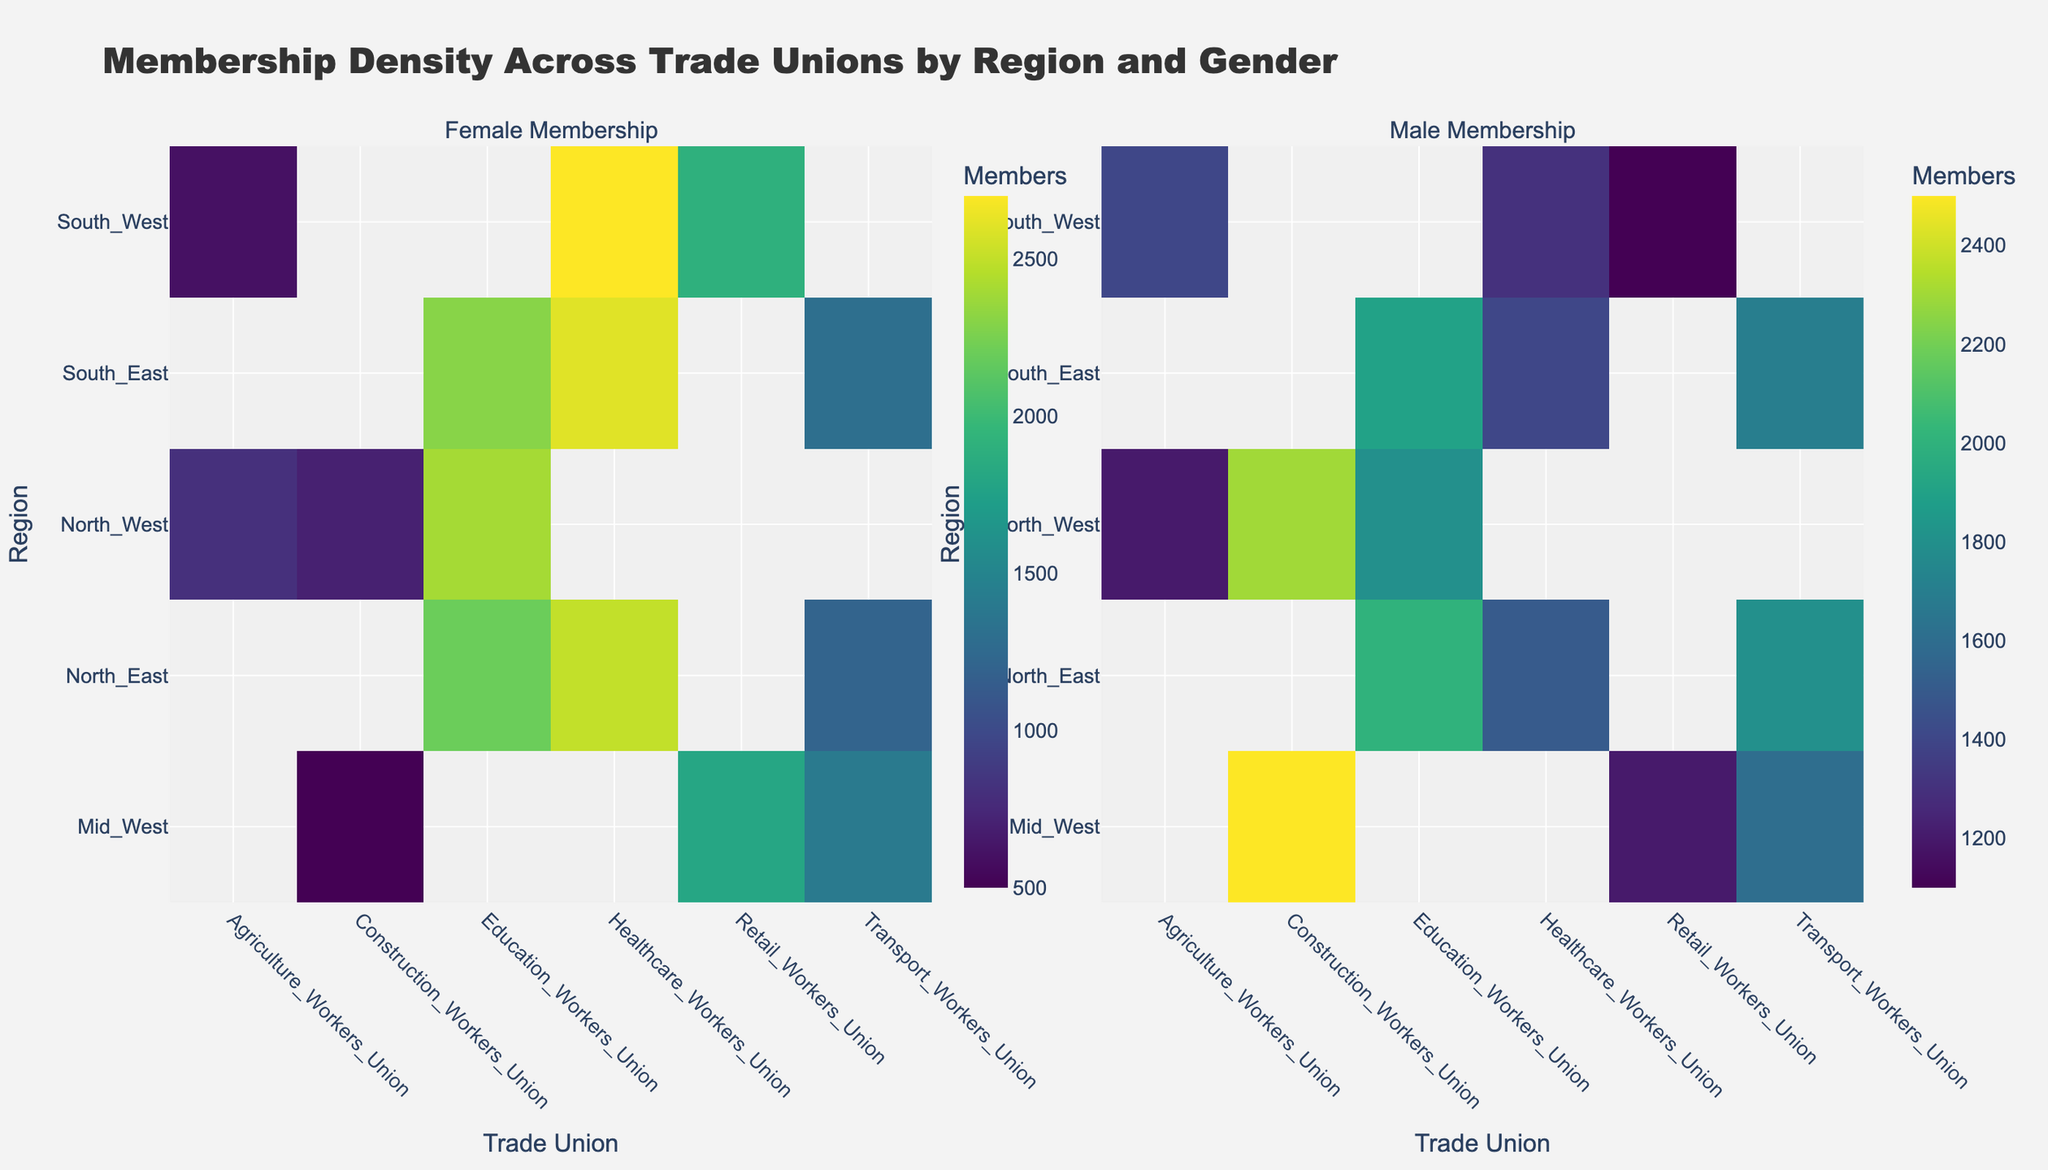How many regions are shown in the heatmap? The heatmap displays regions along the y-axis. By counting the distinct labels, we see there are five regions: North East, Mid West, South West, North West, and South East.
Answer: Five regions Which trade union shows the highest female membership in the North East region? Locate the North East region on the y-axis, then check the cells corresponding to this region under each trade union. The Education Workers Union shows the brightest cell, indicating the highest membership.
Answer: Education Workers Union In which region does the Agriculture Workers Union have the highest male membership? Locate the cells representing the Agriculture Workers Union for all regions on the male membership heatmap. Compare the intensity of these cells. The brightest cell is in the South West region.
Answer: South West What is the total female membership for all trade unions in the South East region? Sum the female membership values for each trade union in the South East region from the female membership heatmap. Transport Workers Union (1300) + Healthcare Workers Union (2600) + Education Workers Union (2300) = 6200 members.
Answer: 6200 members Compare the female membership of the Healthcare Workers Union between North East and South West regions. Which one is higher and by how much? Locate the cells for the Healthcare Workers Union in the North East and South West regions on the female membership heatmap. North East has 2500 members and South West has 2700 members. The South West has 2700 - 2500 = 200 members more.
Answer: South West by 200 members Identify the region with the least female membership in the Construction Workers Union. Locate the Construction Workers Union column on the female membership heatmap. Among the regions, the dimmest cell is in North West, indicating the least membership.
Answer: North West Which trade union shows the most balanced gender membership in the Mid West region? For the Mid West region, compare the cells in the female and male membership heatmaps. The Retail Workers Union shows nearly equal brightness in both maps, indicating a balanced membership.
Answer: Retail Workers Union What is the difference in male membership between the Transport Workers Union in the North West and the North East regions? Locate the Transport Workers Union cells for the North West and North East regions in the male membership heatmap. The North West has 1800 members and the North East also has 1800 members, so the difference is 0.
Answer: 0 members Which region has the highest combined membership across all trade unions? Sum the male and female memberships for each region across all trade unions. The North East (3000+4000+4200) has the highest combined membership (11200).
Answer: North East Which trade union exhibits the largest disparity in membership density by gender across all regions? Compare the differences in brightness between corresponding cells in the male and female membership heatmaps for each trade union. The Construction Workers Union shows the largest disparity between male and female memberships.
Answer: Construction Workers Union 